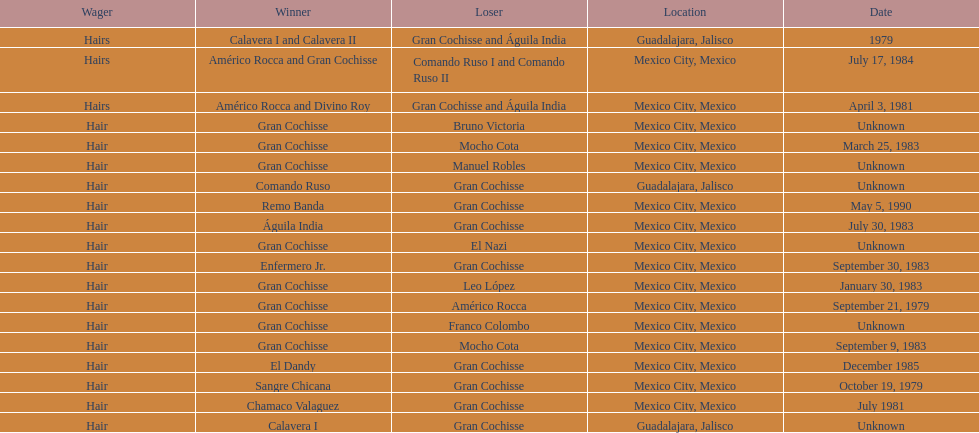What was the number of losses gran cochisse had against el dandy? 1. 